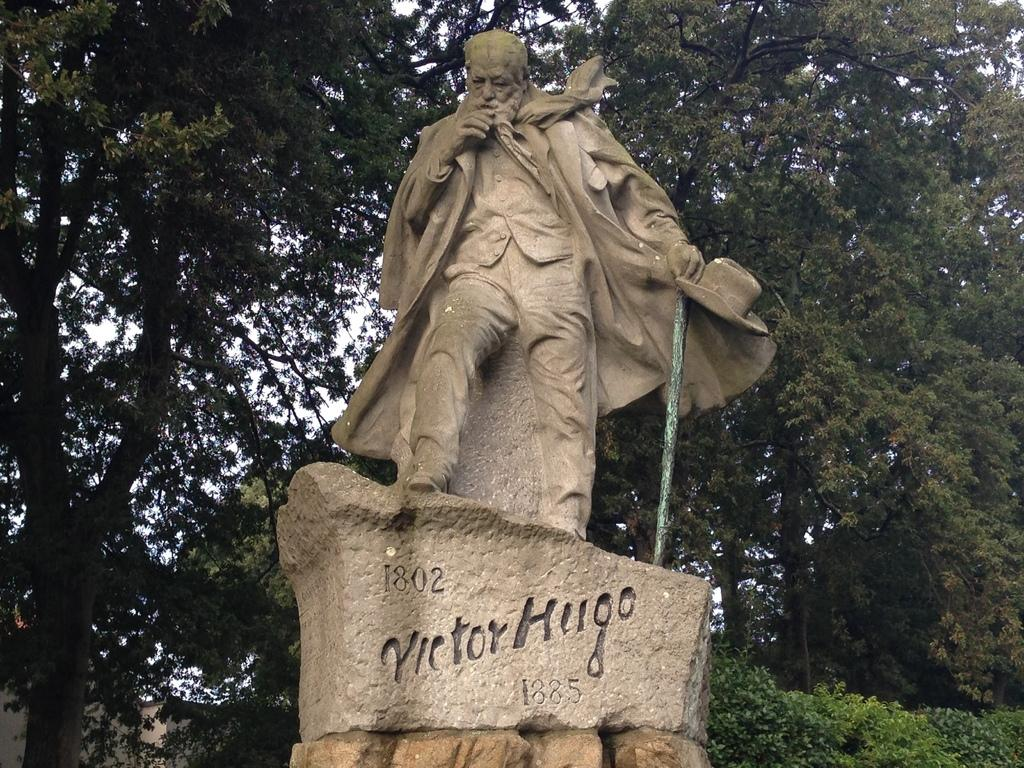What is the main subject in the image? There is a statue in the image. What is the statue standing on? There is a pedestal in the image. What type of natural elements can be seen in the image? There are trees in the image. What is visible in the background of the image? The sky is visible in the image. What type of soda is being poured from the chain in the image? There is no soda or chain present in the image. How many trips does the statue take in the image? The statue does not take any trips in the image; it is stationary. 